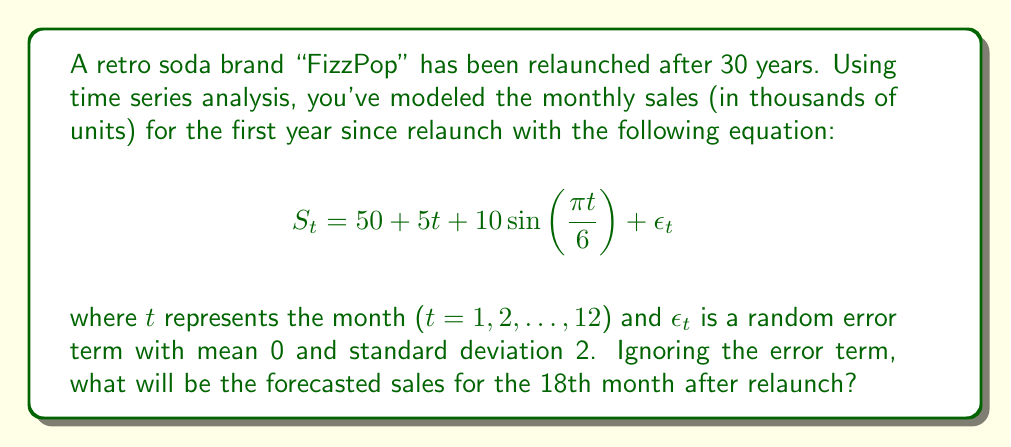Could you help me with this problem? To solve this problem, we'll follow these steps:

1) The given time series model is:
   $$S_t = 50 + 5t + 10\sin(\frac{\pi t}{6}) + \epsilon_t$$

2) We're asked to ignore the error term $\epsilon_t$, so our working equation becomes:
   $$S_t = 50 + 5t + 10\sin(\frac{\pi t}{6})$$

3) We need to forecast for the 18th month, so we'll substitute t = 18:
   $$S_{18} = 50 + 5(18) + 10\sin(\frac{\pi (18)}{6})$$

4) Let's solve each part:
   - $50$ remains as is
   - $5(18) = 90$
   - For the sine term: $\frac{\pi (18)}{6} = 3\pi = \pi + \pi + \pi$
     Since sine has a period of $2\pi$, $\sin(3\pi) = \sin(\pi) = 0$

5) Therefore:
   $$S_{18} = 50 + 90 + 10(0) = 140$$

Thus, the forecasted sales for the 18th month after relaunch will be 140 thousand units.
Answer: 140 thousand units 